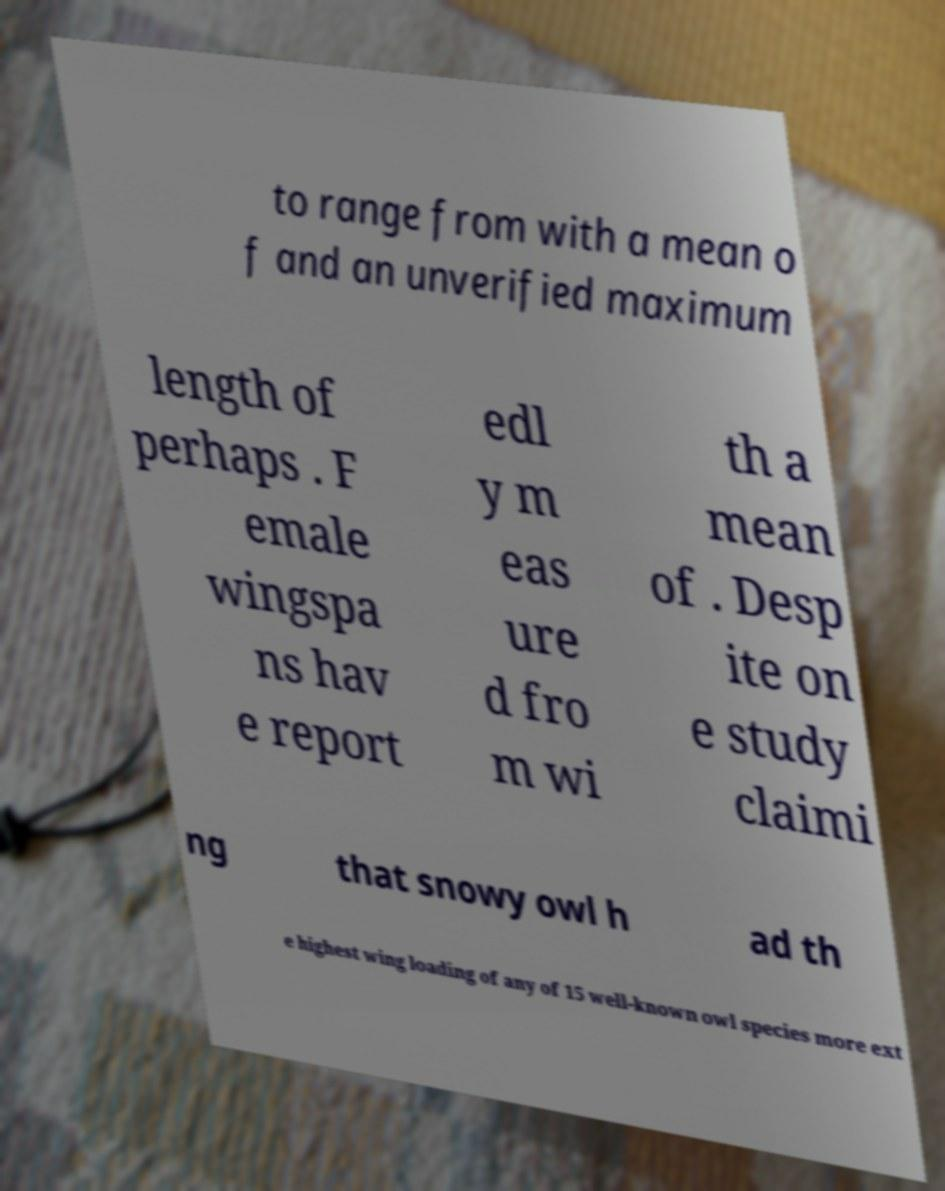Please identify and transcribe the text found in this image. to range from with a mean o f and an unverified maximum length of perhaps . F emale wingspa ns hav e report edl y m eas ure d fro m wi th a mean of . Desp ite on e study claimi ng that snowy owl h ad th e highest wing loading of any of 15 well-known owl species more ext 